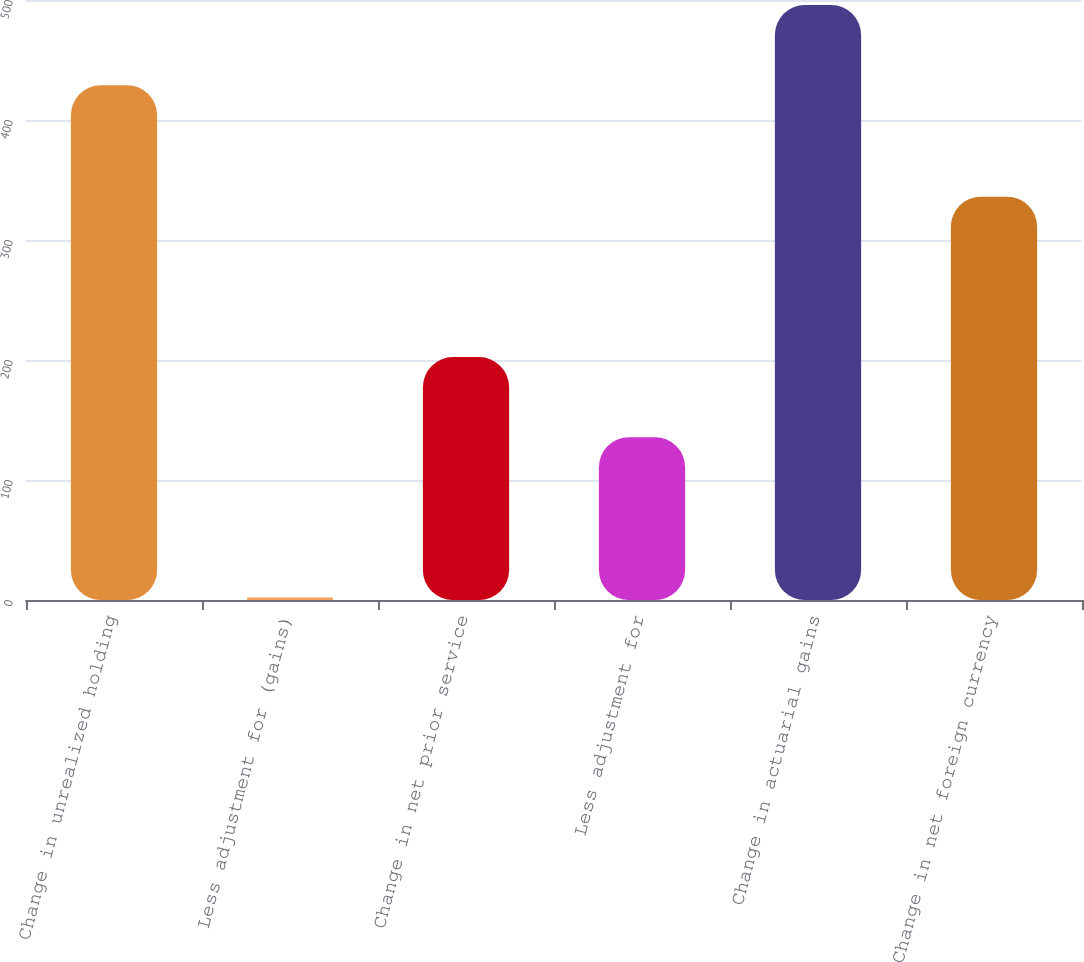Convert chart. <chart><loc_0><loc_0><loc_500><loc_500><bar_chart><fcel>Change in unrealized holding<fcel>Less adjustment for (gains)<fcel>Change in net prior service<fcel>Less adjustment for<fcel>Change in actuarial gains<fcel>Change in net foreign currency<nl><fcel>429<fcel>2<fcel>202.4<fcel>135.6<fcel>495.8<fcel>336<nl></chart> 